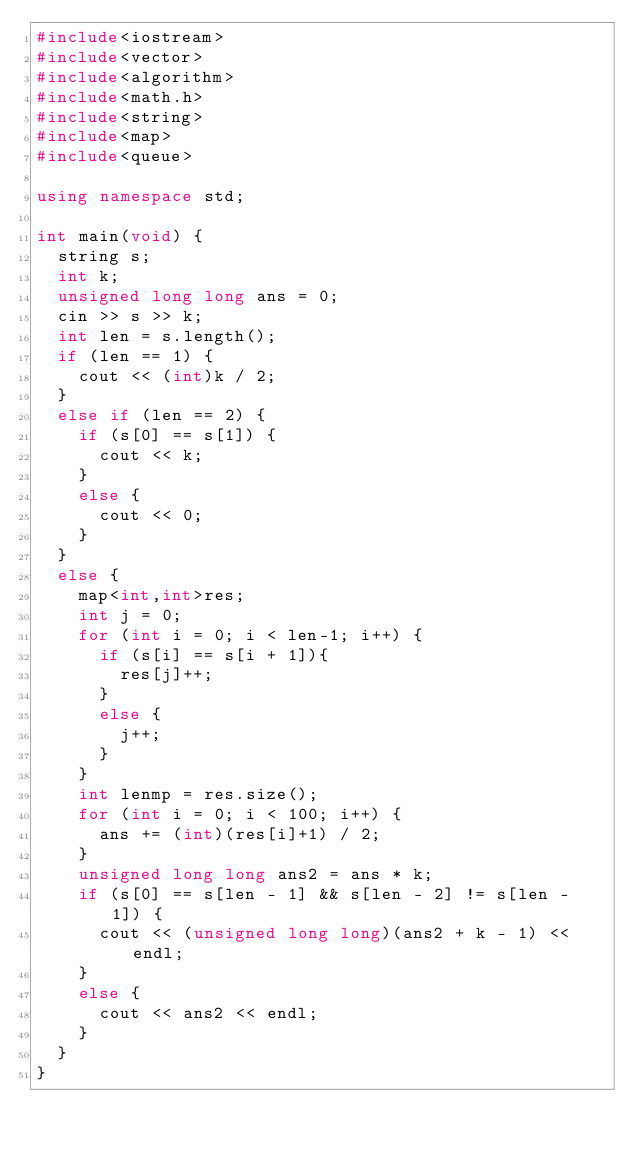Convert code to text. <code><loc_0><loc_0><loc_500><loc_500><_C++_>#include<iostream>
#include<vector>
#include<algorithm>
#include<math.h>
#include<string>
#include<map>
#include<queue>

using namespace std;

int main(void) {
	string s;
	int k;
	unsigned long long ans = 0;
	cin >> s >> k;
	int len = s.length();
	if (len == 1) {
		cout << (int)k / 2;
	}
	else if (len == 2) {
		if (s[0] == s[1]) {
			cout << k;
		}
		else {
			cout << 0;
		}
	}
	else {
		map<int,int>res;
		int j = 0;
		for (int i = 0; i < len-1; i++) {
			if (s[i] == s[i + 1]){
				res[j]++;
			}
			else {
				j++;
			}
		}
		int lenmp = res.size();
		for (int i = 0; i < 100; i++) {
			ans += (int)(res[i]+1) / 2;
		}
		unsigned long long ans2 = ans * k;
		if (s[0] == s[len - 1] && s[len - 2] != s[len - 1]) {
			cout << (unsigned long long)(ans2 + k - 1) << endl;
		}
		else {
			cout << ans2 << endl;
		}
	}
}
</code> 